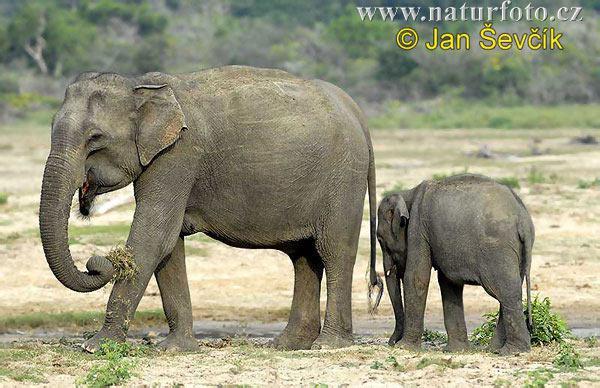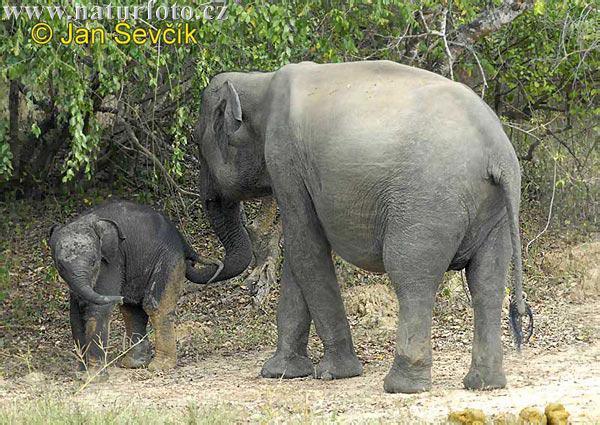The first image is the image on the left, the second image is the image on the right. Assess this claim about the two images: "Each image contains multiple elephants, and the right image includes a baby elephant.". Correct or not? Answer yes or no. Yes. The first image is the image on the left, the second image is the image on the right. For the images displayed, is the sentence "There are no baby elephants in the images." factually correct? Answer yes or no. No. 